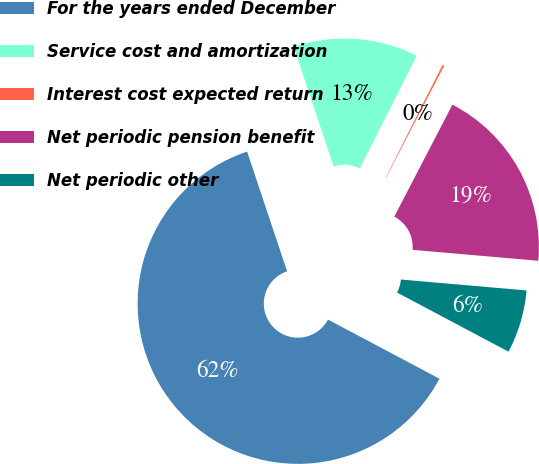Convert chart. <chart><loc_0><loc_0><loc_500><loc_500><pie_chart><fcel>For the years ended December<fcel>Service cost and amortization<fcel>Interest cost expected return<fcel>Net periodic pension benefit<fcel>Net periodic other<nl><fcel>62.11%<fcel>12.57%<fcel>0.18%<fcel>18.76%<fcel>6.38%<nl></chart> 